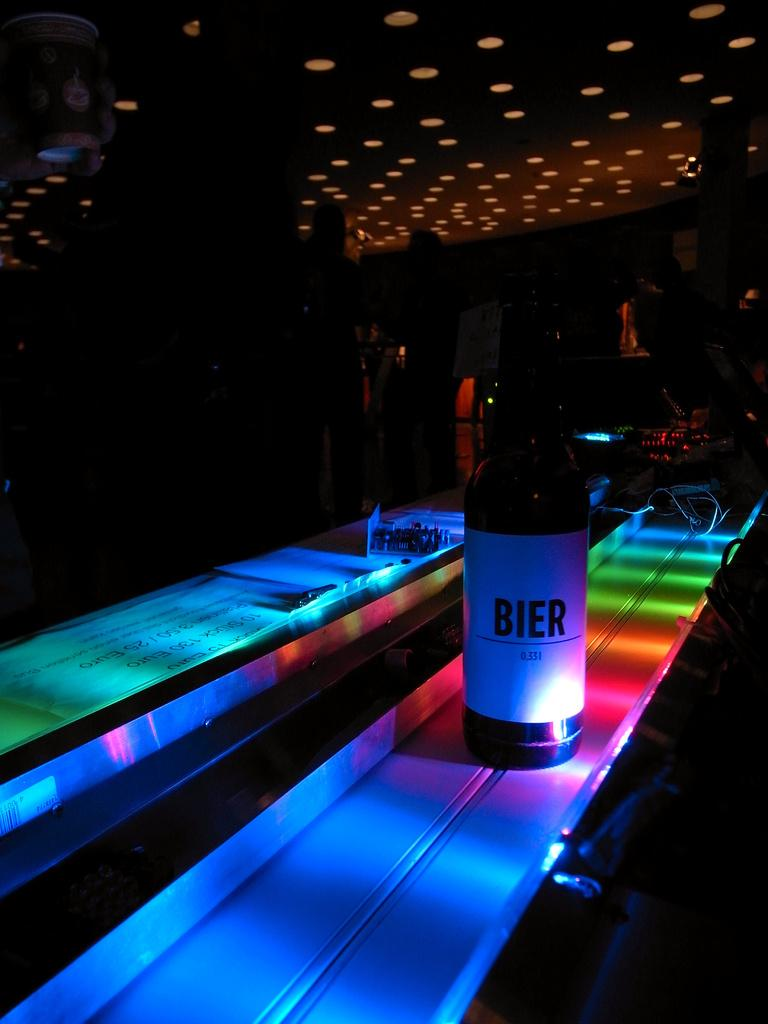<image>
Relay a brief, clear account of the picture shown. A colorful lighted bar has a bottle of BIER on it. 